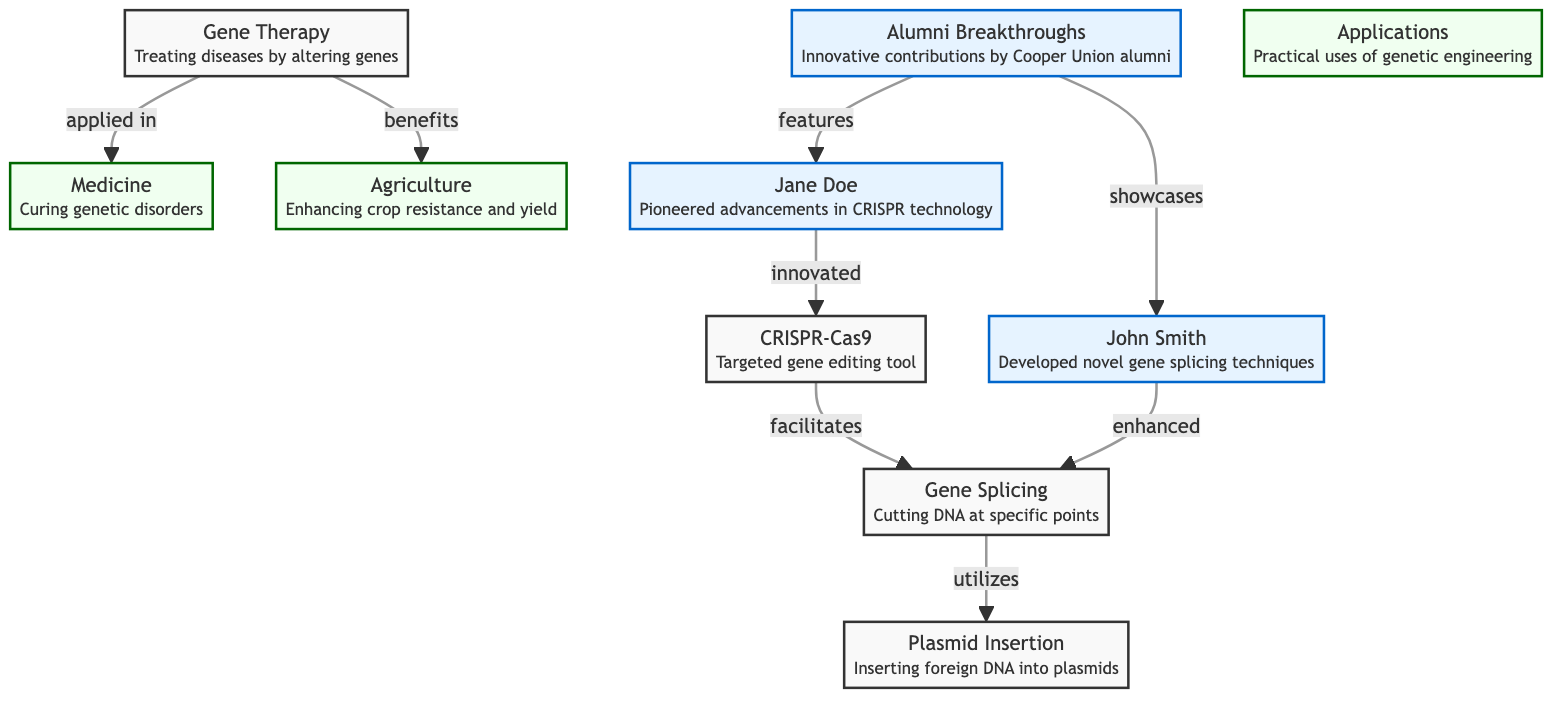What are the two main techniques introduced by alumni? The diagram shows that Jane Doe pioneered advancements in CRISPR technology and John Smith developed novel gene splicing techniques. These two specific contributions are highlighted in the alumni section.
Answer: CRISPR and gene splicing How many alumni breakthroughs are featured in the diagram? The diagram explicitly mentions two alumni breakthroughs: one by Jane Doe and one by John Smith. By counting these individuals listed under the alumni section, we find the total number.
Answer: 2 Which application benefits from gene therapy? The diagram indicates that gene therapy is applied in medicine and also benefits agriculture. By identifying the connections from the gene therapy node, we can see the applications directly linked.
Answer: Medicine and agriculture What is the relationship between CRISPR and gene splicing? According to the diagram, CRISPR facilitates gene splicing. This relationship is indicated by an arrow connecting the CRISPR node to the gene splicing node, demonstrating a directional influence.
Answer: Facilitates How does alumni innovation impact genetic engineering? The diagram shows that Jane Doe innovated CRISPR and John Smith enhanced gene splicing, thus indicating that alumni contributions significantly influence advancements in genetic engineering as depicted by the outgoing arrows.
Answer: Innovated and enhanced Which concepts are connected to agriculture in the diagram? The diagram connects agriculture to gene therapy, indicating that gene therapy benefits agriculture. By following the flow from gene therapy, we can determine the applications relevant to agriculture.
Answer: Gene therapy What color represents the alumni section in the diagram? The alumni section is represented by a light blue fill color (#e6f3ff) with a darker stroke (#0066cc). By observing the styling attributes assigned, we can identify its distinctive coloration.
Answer: Light blue Which node utilizes plasmid insertion? The diagram indicates that the gene splicing node utilizes plasmid insertion. This shows a direct link where gene splicing is dependent on plasmid insertion for its process.
Answer: Gene splicing 